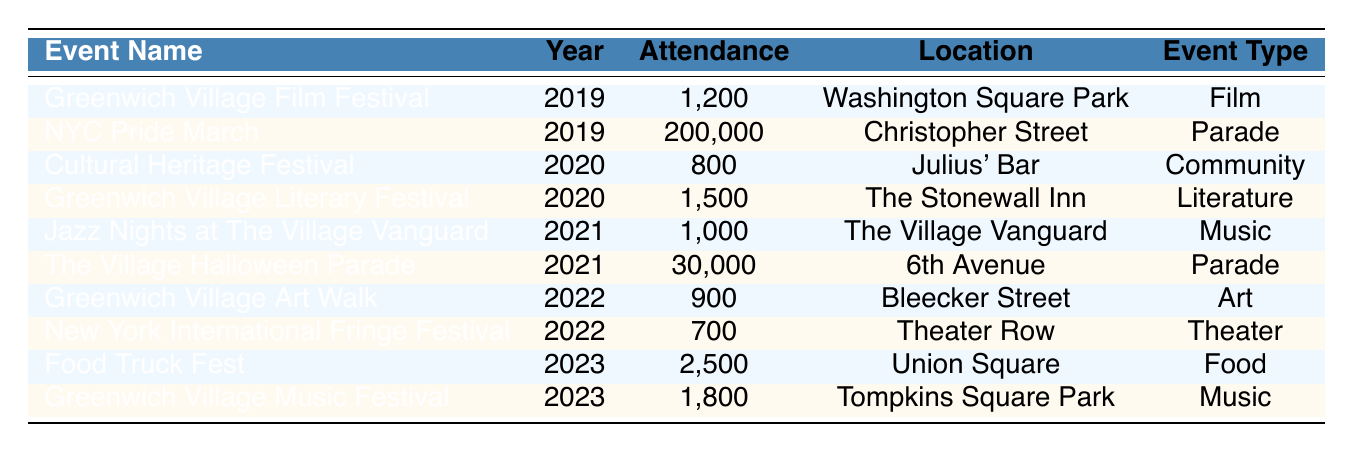What was the attendance for the NYC Pride March in 2019? The table shows a row for the NYC Pride March under the year 2019 with an attendance figure of 200,000.
Answer: 200,000 Which event had the highest attendance in 2021? In 2021, the table lists two events: Jazz Nights at The Village Vanguard with 1,000 attendees and The Village Halloween Parade with 30,000 attendees. Comparing these figures, The Village Halloween Parade had the highest attendance.
Answer: The Village Halloween Parade What is the total attendance for cultural events in 2022? The events listed for 2022 are Greenwich Village Art Walk (900) and New York International Fringe Festival (700). Adding these together: 900 + 700 = 1,600.
Answer: 1,600 Did the attendance for cultural events increase or decrease from 2020 to 2021? In 2020, the total attendance was 800 (Cultural Heritage Festival) + 1,500 (Greenwich Village Literary Festival) = 2,300. In 2021, the attendance was 1,000 (Jazz Nights at The Village Vanguard) + 30,000 (The Village Halloween Parade) = 31,000. Since 31,000 is greater than 2,300, attendance increased.
Answer: Yes What is the average attendance for music events over these five years? The music events listed are: Jazz Nights at The Village Vanguard (1,000 in 2021), Greenwich Village Music Festival (1,800 in 2023), and attendance for two more music events is unknown. To find the average, we only consider listed events. Total attendance for music events = 1,000 + 1,800 = 2,800 with 2 events: 2,800 / 2 = 1,400.
Answer: 1,400 